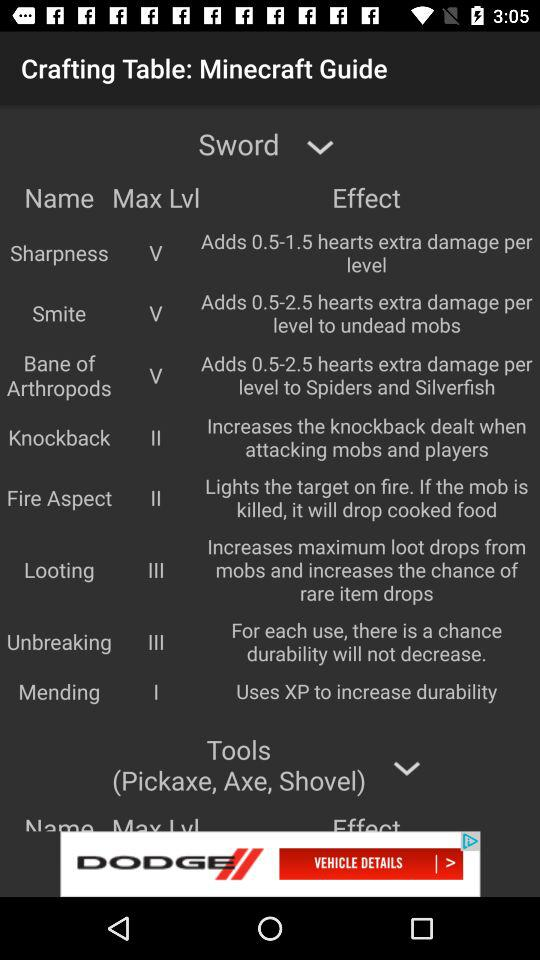What is the "Mending" maximum level? The maximum level of mending is "first". 